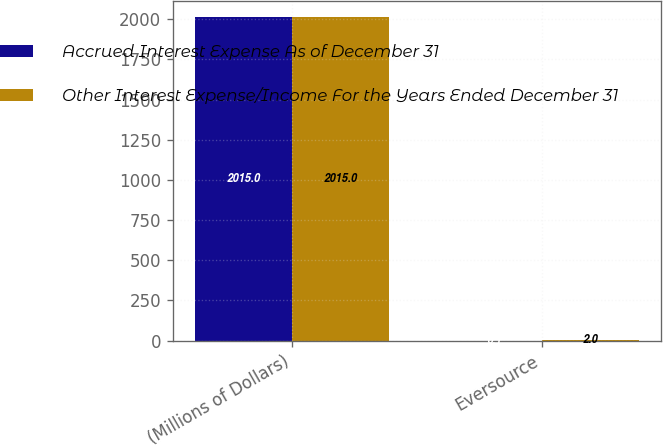<chart> <loc_0><loc_0><loc_500><loc_500><stacked_bar_chart><ecel><fcel>(Millions of Dollars)<fcel>Eversource<nl><fcel>Accrued Interest Expense As of December 31<fcel>2015<fcel>0.1<nl><fcel>Other Interest Expense/Income For the Years Ended December 31<fcel>2015<fcel>2<nl></chart> 